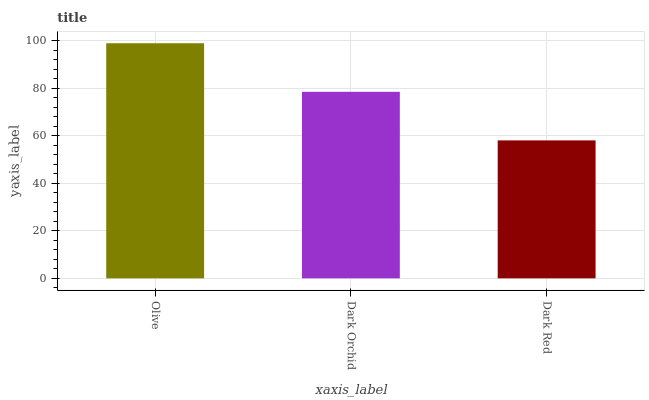Is Dark Red the minimum?
Answer yes or no. Yes. Is Olive the maximum?
Answer yes or no. Yes. Is Dark Orchid the minimum?
Answer yes or no. No. Is Dark Orchid the maximum?
Answer yes or no. No. Is Olive greater than Dark Orchid?
Answer yes or no. Yes. Is Dark Orchid less than Olive?
Answer yes or no. Yes. Is Dark Orchid greater than Olive?
Answer yes or no. No. Is Olive less than Dark Orchid?
Answer yes or no. No. Is Dark Orchid the high median?
Answer yes or no. Yes. Is Dark Orchid the low median?
Answer yes or no. Yes. Is Dark Red the high median?
Answer yes or no. No. Is Olive the low median?
Answer yes or no. No. 